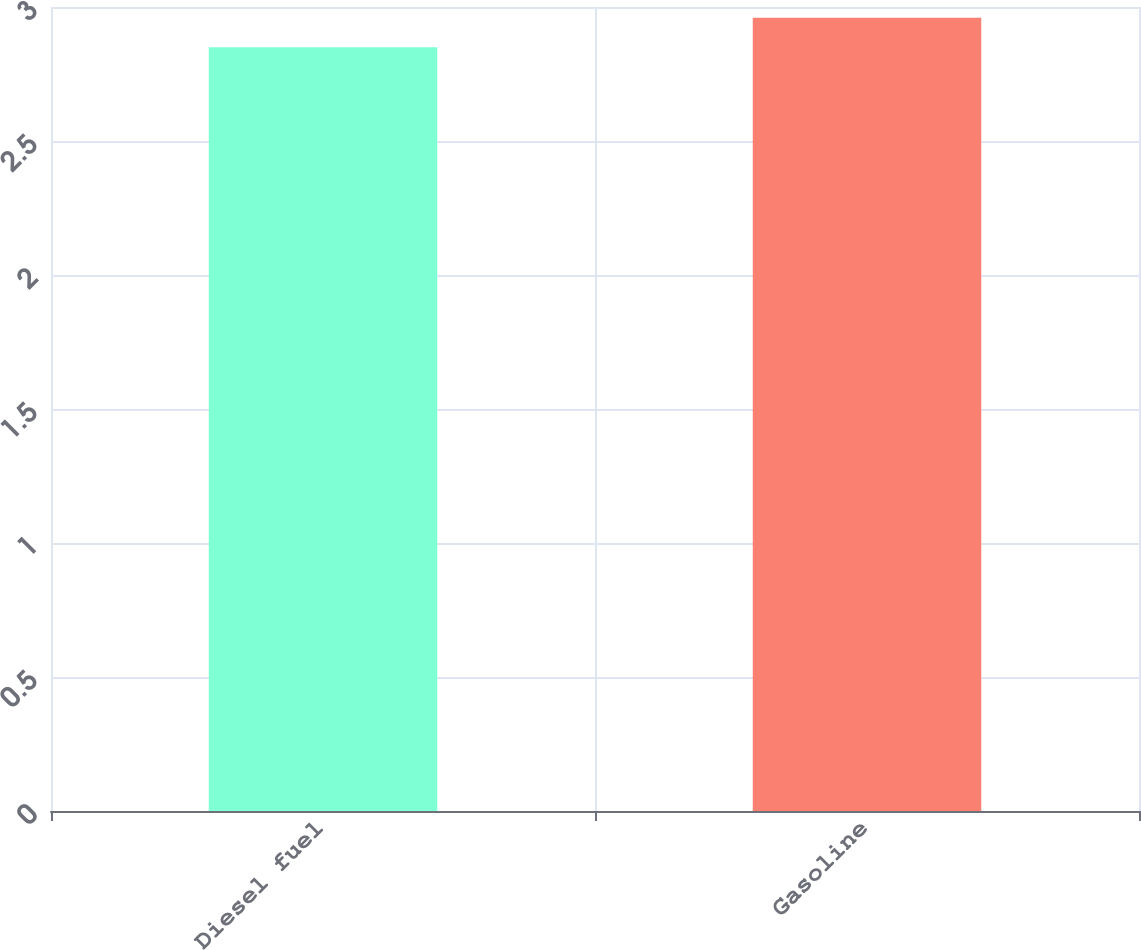<chart> <loc_0><loc_0><loc_500><loc_500><bar_chart><fcel>Diesel fuel<fcel>Gasoline<nl><fcel>2.85<fcel>2.96<nl></chart> 